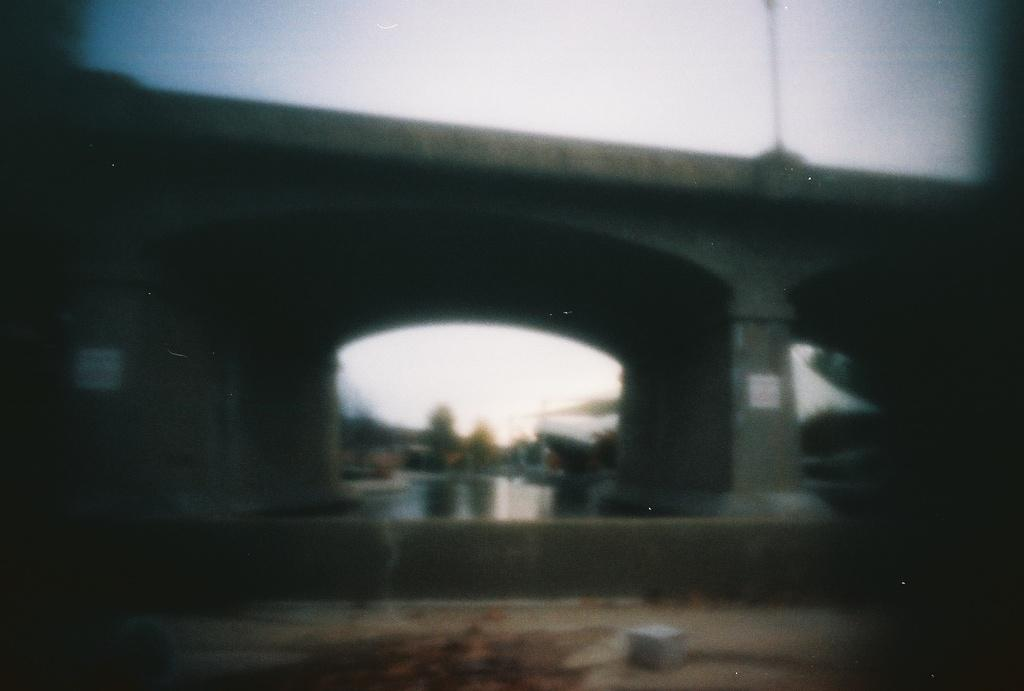What type of structure can be seen in the image? There is a bridge in the image. What natural element is visible in the image? There is water visible in the image. What else can be seen in the sky in the image? The sky is visible in the image. What type of bucket is being used to serve the meal in the image? There is no bucket or meal present in the image; it only features a bridge and water. 